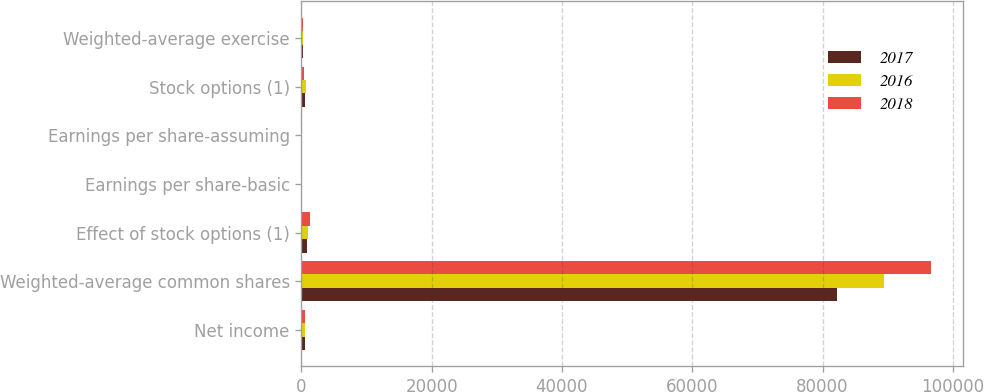<chart> <loc_0><loc_0><loc_500><loc_500><stacked_bar_chart><ecel><fcel>Net income<fcel>Weighted-average common shares<fcel>Effect of stock options (1)<fcel>Earnings per share-basic<fcel>Earnings per share-assuming<fcel>Stock options (1)<fcel>Weighted-average exercise<nl><fcel>2017<fcel>567<fcel>82280<fcel>874<fcel>16.27<fcel>16.1<fcel>567<fcel>268.55<nl><fcel>2016<fcel>567<fcel>89502<fcel>1076<fcel>12.82<fcel>12.67<fcel>715<fcel>252.16<nl><fcel>2018<fcel>567<fcel>96720<fcel>1273<fcel>10.87<fcel>10.73<fcel>332<fcel>265.77<nl></chart> 